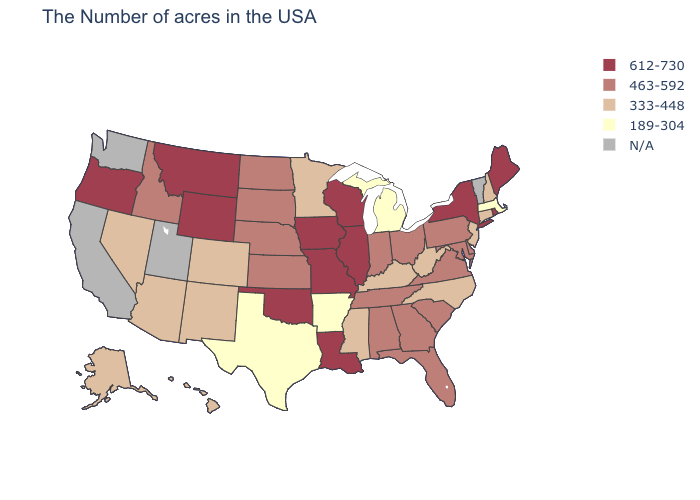Name the states that have a value in the range 612-730?
Write a very short answer. Maine, Rhode Island, New York, Wisconsin, Illinois, Louisiana, Missouri, Iowa, Oklahoma, Wyoming, Montana, Oregon. Is the legend a continuous bar?
Give a very brief answer. No. Name the states that have a value in the range 189-304?
Give a very brief answer. Massachusetts, Michigan, Arkansas, Texas. Among the states that border Arkansas , does Texas have the lowest value?
Answer briefly. Yes. What is the value of Pennsylvania?
Quick response, please. 463-592. What is the lowest value in states that border Georgia?
Short answer required. 333-448. Name the states that have a value in the range 333-448?
Keep it brief. New Hampshire, Connecticut, New Jersey, North Carolina, West Virginia, Kentucky, Mississippi, Minnesota, Colorado, New Mexico, Arizona, Nevada, Alaska, Hawaii. What is the value of Kentucky?
Give a very brief answer. 333-448. What is the value of Arkansas?
Give a very brief answer. 189-304. What is the lowest value in the West?
Quick response, please. 333-448. Name the states that have a value in the range 463-592?
Keep it brief. Delaware, Maryland, Pennsylvania, Virginia, South Carolina, Ohio, Florida, Georgia, Indiana, Alabama, Tennessee, Kansas, Nebraska, South Dakota, North Dakota, Idaho. Does the first symbol in the legend represent the smallest category?
Quick response, please. No. What is the highest value in the MidWest ?
Give a very brief answer. 612-730. What is the value of New York?
Concise answer only. 612-730. 